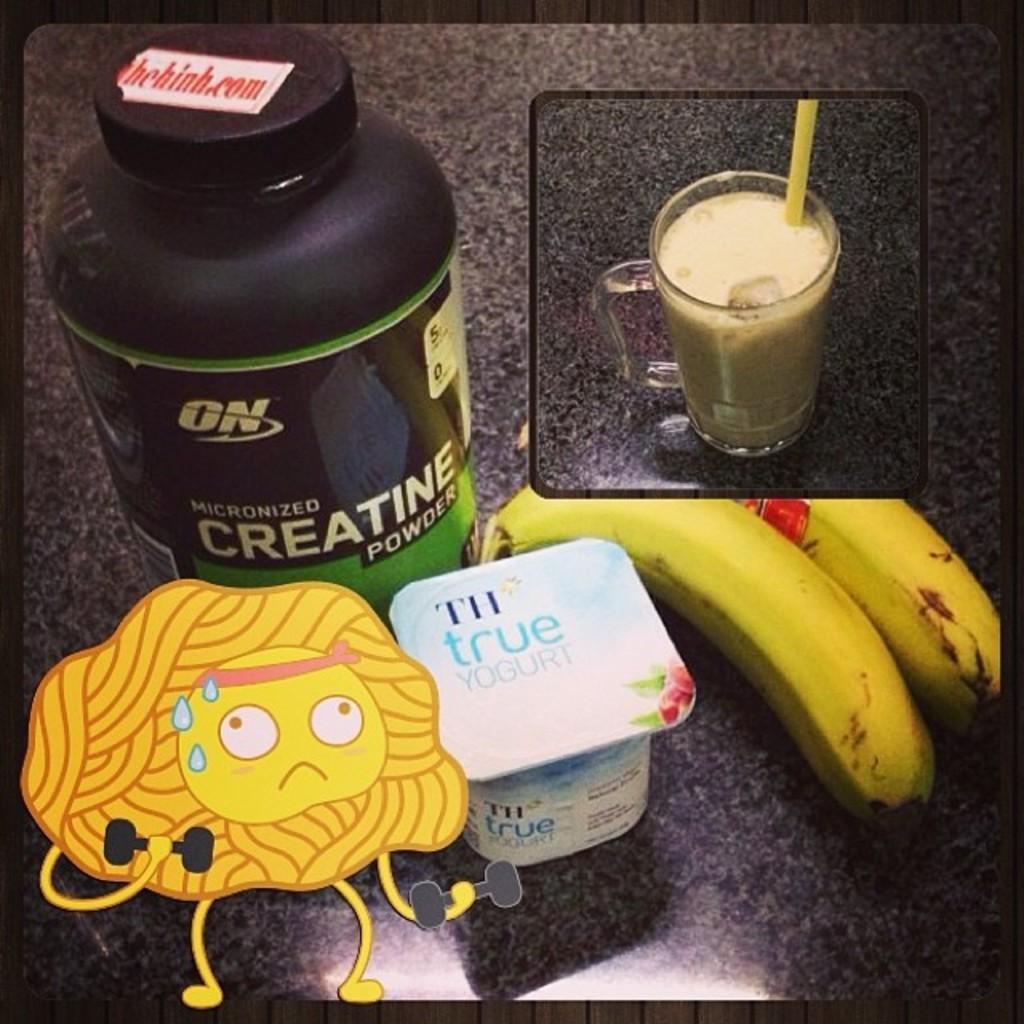In one or two sentences, can you explain what this image depicts? In this image I can see bananas, glass and some other objects on surface. Here I can see a cartoon on the image. 